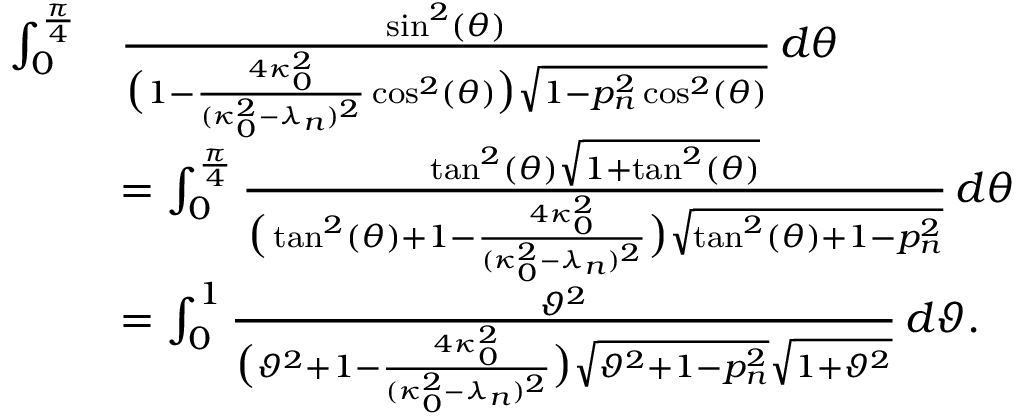Convert formula to latex. <formula><loc_0><loc_0><loc_500><loc_500>\begin{array} { r l } { \int _ { 0 } ^ { \frac { \pi } { 4 } } } & { \frac { \sin ^ { 2 } ( \theta ) } { \left ( 1 - \frac { 4 \kappa _ { 0 } ^ { 2 } } { ( \kappa _ { 0 } ^ { 2 } - \lambda _ { n } ) ^ { 2 } } \cos ^ { 2 } ( \theta ) \right ) \sqrt { 1 - p _ { n } ^ { 2 } \cos ^ { 2 } ( \theta ) } } \, d \theta } \\ & { = \int _ { 0 } ^ { \frac { \pi } { 4 } } \frac { \tan ^ { 2 } ( \theta ) \sqrt { 1 + \tan ^ { 2 } ( \theta ) } } { \left ( \tan ^ { 2 } ( \theta ) + 1 - \frac { 4 \kappa _ { 0 } ^ { 2 } } { ( \kappa _ { 0 } ^ { 2 } - \lambda _ { n } ) ^ { 2 } } \right ) \sqrt { \tan ^ { 2 } ( \theta ) + 1 - p _ { n } ^ { 2 } } } \, d \theta } \\ & { = \int _ { 0 } ^ { 1 } \frac { \vartheta ^ { 2 } } { \left ( \vartheta ^ { 2 } + 1 - \frac { 4 \kappa _ { 0 } ^ { 2 } } { ( \kappa _ { 0 } ^ { 2 } - \lambda _ { n } ) ^ { 2 } } \right ) \sqrt { \vartheta ^ { 2 } + 1 - p _ { n } ^ { 2 } } \sqrt { 1 + \vartheta ^ { 2 } } } \, d \vartheta . } \end{array}</formula> 